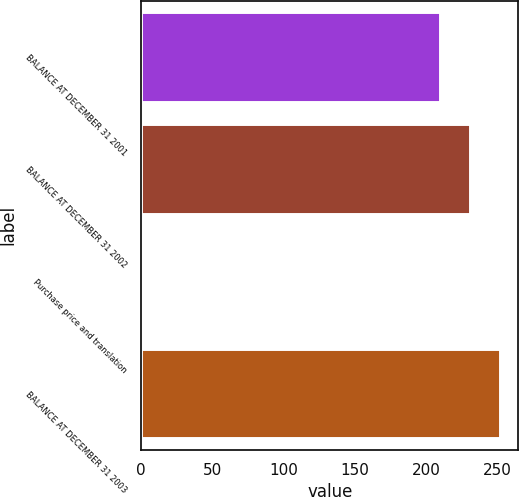Convert chart. <chart><loc_0><loc_0><loc_500><loc_500><bar_chart><fcel>BALANCE AT DECEMBER 31 2001<fcel>BALANCE AT DECEMBER 31 2002<fcel>Purchase price and translation<fcel>BALANCE AT DECEMBER 31 2003<nl><fcel>210<fcel>231<fcel>1<fcel>252<nl></chart> 